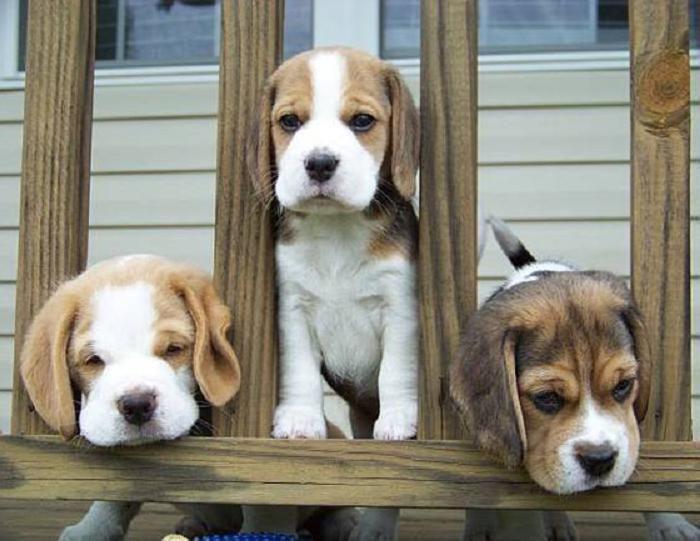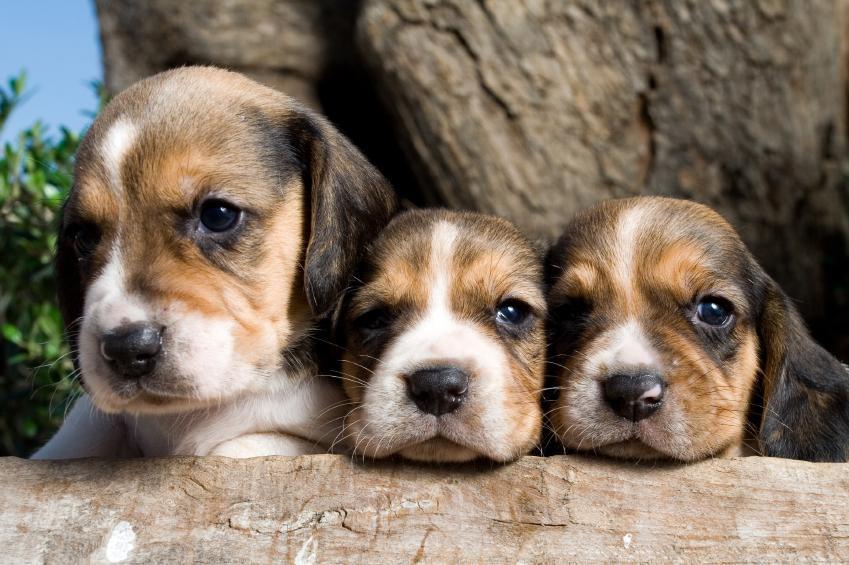The first image is the image on the left, the second image is the image on the right. Given the left and right images, does the statement "One image shows three hounds posed on a rail, with the one in the middle taller than the others, and the other image shows three side-by-side dogs with the leftmost looking taller." hold true? Answer yes or no. Yes. The first image is the image on the left, the second image is the image on the right. For the images displayed, is the sentence "There are three dogs in the grass in at least one of the images." factually correct? Answer yes or no. No. 